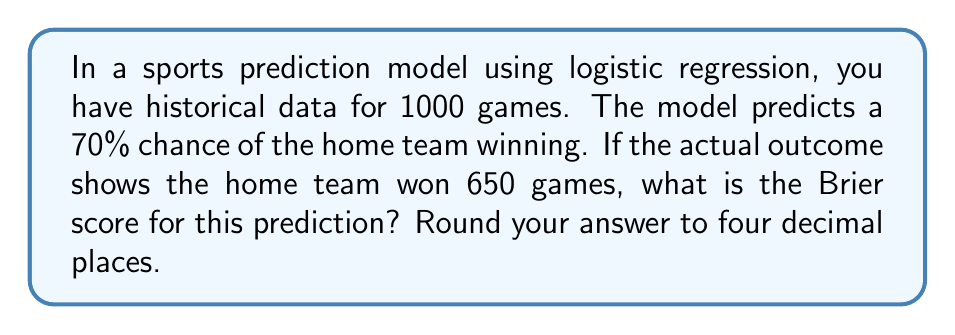Teach me how to tackle this problem. To solve this problem, we'll use the Brier score formula and follow these steps:

1) The Brier score is a measure of the accuracy of probabilistic predictions, calculated as:

   $$BS = \frac{1}{N} \sum_{i=1}^{N} (f_i - o_i)^2$$

   Where:
   - $N$ is the number of predictions (games in this case)
   - $f_i$ is the predicted probability
   - $o_i$ is the actual outcome (1 for win, 0 for loss)

2) In this case:
   - $N = 1000$ (total games)
   - $f_i = 0.70$ (70% chance of home team winning)
   - For 650 games, $o_i = 1$ (home team won)
   - For 350 games, $o_i = 0$ (home team lost)

3) Let's break down the sum:
   
   $$\sum_{i=1}^{N} (f_i - o_i)^2 = 650(0.70 - 1)^2 + 350(0.70 - 0)^2$$

4) Calculate each part:
   
   $650(0.70 - 1)^2 = 650(-0.30)^2 = 650(0.09) = 58.5$
   $350(0.70 - 0)^2 = 350(0.70)^2 = 350(0.49) = 171.5$

5) Sum these parts:
   
   $58.5 + 171.5 = 230$

6) Divide by $N$ (1000):
   
   $$BS = \frac{230}{1000} = 0.23$$

7) Rounding to four decimal places:
   
   $BS = 0.2300$
Answer: 0.2300 